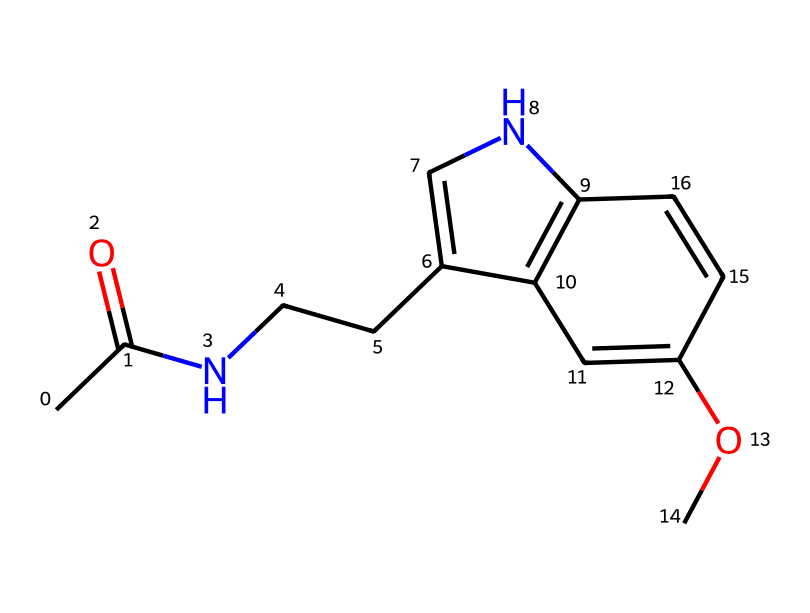how many carbon atoms are in melatonin? By analyzing the SMILES representation, we can count the number of carbon atoms indicated by the letter "C". There are 13 instances of "C" in the SMILES string, meaning there are 13 carbon atoms.
Answer: 13 what type of chemical bond is present between the nitrogen and carbon atoms? In the chemical structure, the nitrogen atom is bonded to carbon atoms by single covalent bonds, which are common in organic compounds like melatonin.
Answer: single covalent bond how many rings are present in the chemical structure? The structure has two distinct cyclic components, which can be identified by looking for the numbers indicating ring closures in the SMILES notation (1 and 2). This indicates that there are two rings.
Answer: 2 which functional group is indicated by the "CC(=O)" part of the SMILES? The "CC(=O)" segment shows that there is a carbon (C) double-bonded to an oxygen (O) atom, characteristic of a carbonyl functional group, specifically an acetyl group in this context.
Answer: acetyl group is melatonin a naturally occurring hormone? Yes, melatonin is known as a natural hormone produced in the pineal gland that regulates sleep cycles in the human body.
Answer: yes what role does melatonin play in regulating biological rhythms? Melatonin is responsible for signaling the body to prepare for sleep by influencing the sleep-wake cycle, thus playing a crucial role as a regulator of circadian rhythms.
Answer: regulates sleep cycles 